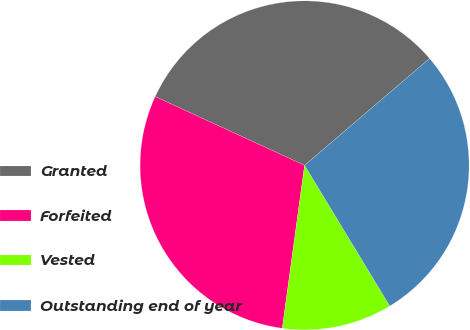<chart> <loc_0><loc_0><loc_500><loc_500><pie_chart><fcel>Granted<fcel>Forfeited<fcel>Vested<fcel>Outstanding end of year<nl><fcel>31.88%<fcel>29.7%<fcel>10.83%<fcel>27.59%<nl></chart> 